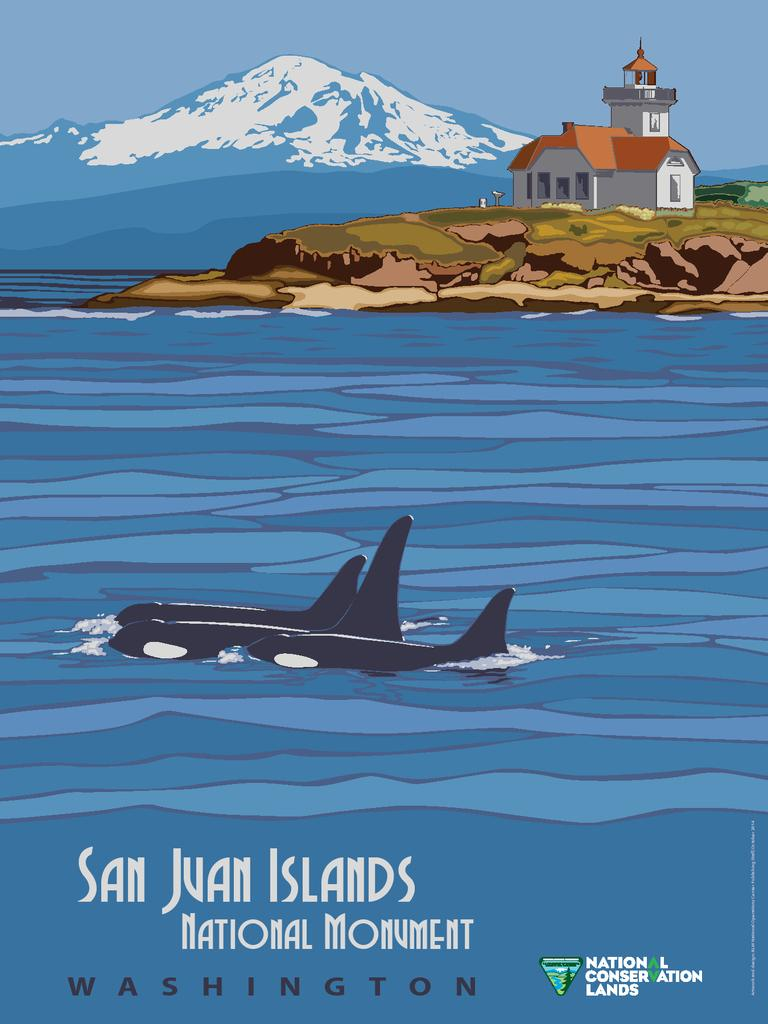<image>
Describe the image concisely. A poster with killer whales swimming by a light house that says San Juan Islands. 